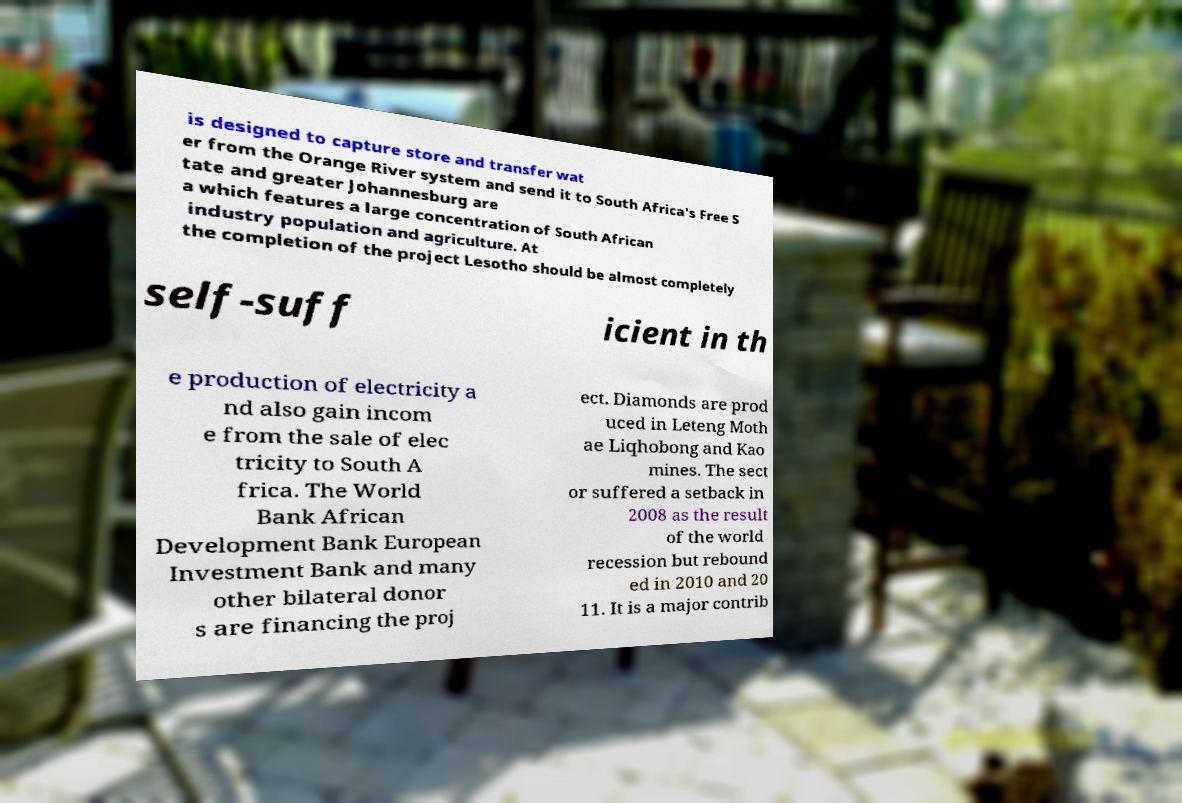What messages or text are displayed in this image? I need them in a readable, typed format. is designed to capture store and transfer wat er from the Orange River system and send it to South Africa's Free S tate and greater Johannesburg are a which features a large concentration of South African industry population and agriculture. At the completion of the project Lesotho should be almost completely self-suff icient in th e production of electricity a nd also gain incom e from the sale of elec tricity to South A frica. The World Bank African Development Bank European Investment Bank and many other bilateral donor s are financing the proj ect. Diamonds are prod uced in Leteng Moth ae Liqhobong and Kao mines. The sect or suffered a setback in 2008 as the result of the world recession but rebound ed in 2010 and 20 11. It is a major contrib 